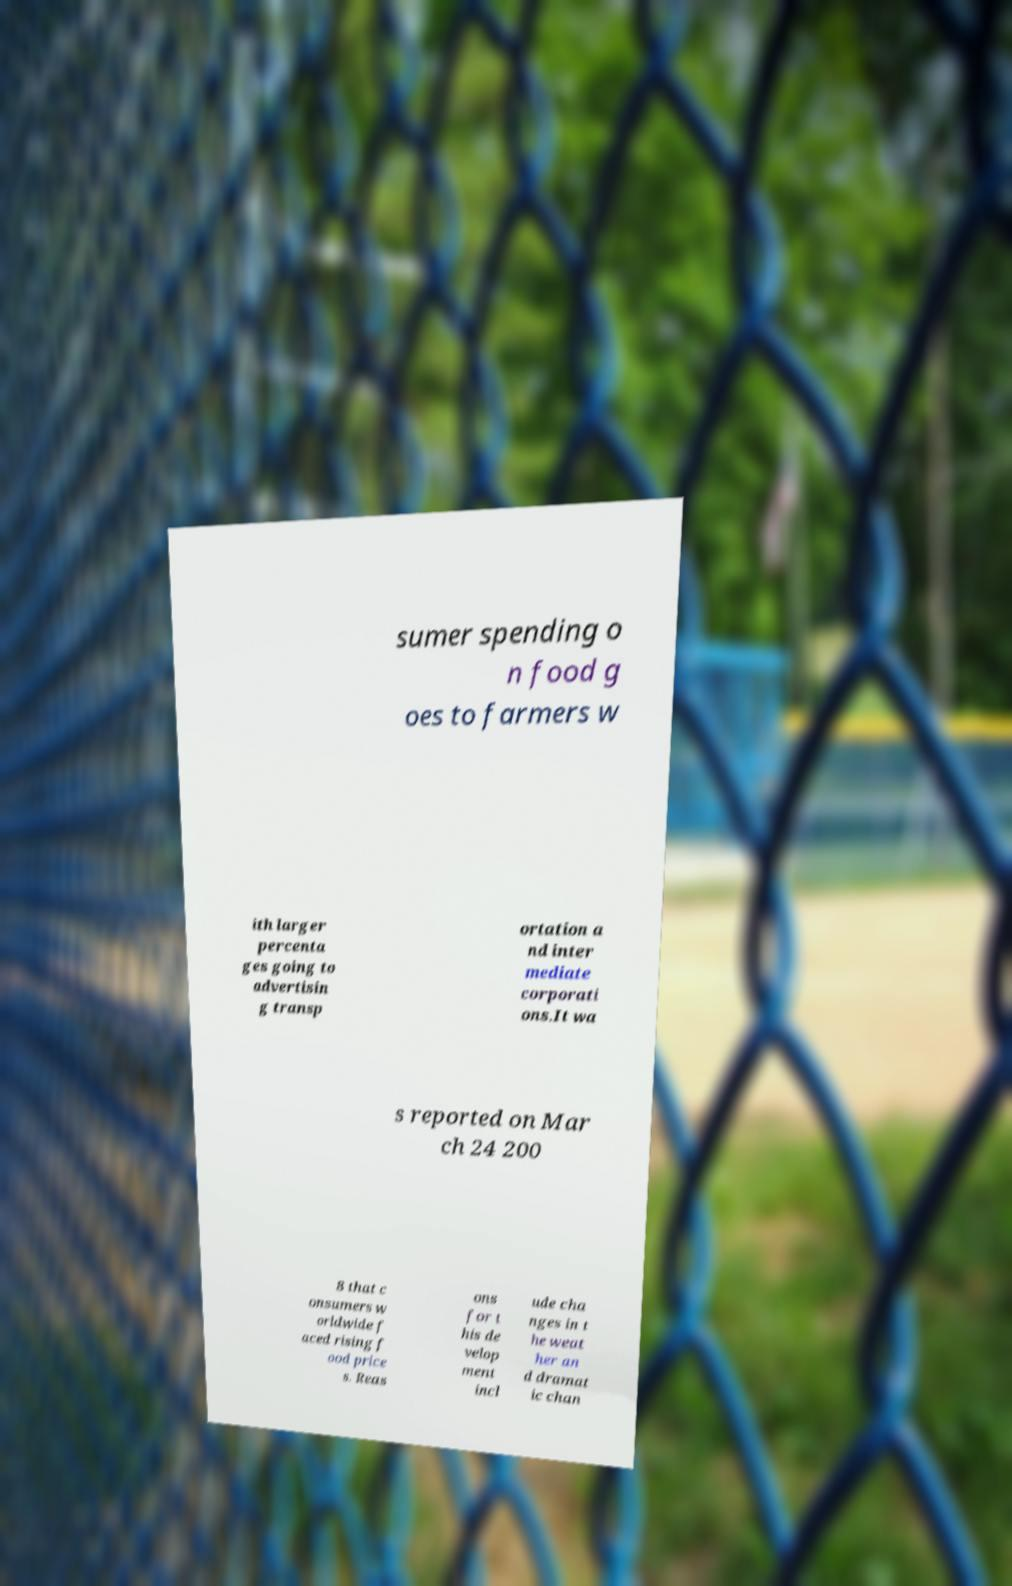For documentation purposes, I need the text within this image transcribed. Could you provide that? sumer spending o n food g oes to farmers w ith larger percenta ges going to advertisin g transp ortation a nd inter mediate corporati ons.It wa s reported on Mar ch 24 200 8 that c onsumers w orldwide f aced rising f ood price s. Reas ons for t his de velop ment incl ude cha nges in t he weat her an d dramat ic chan 